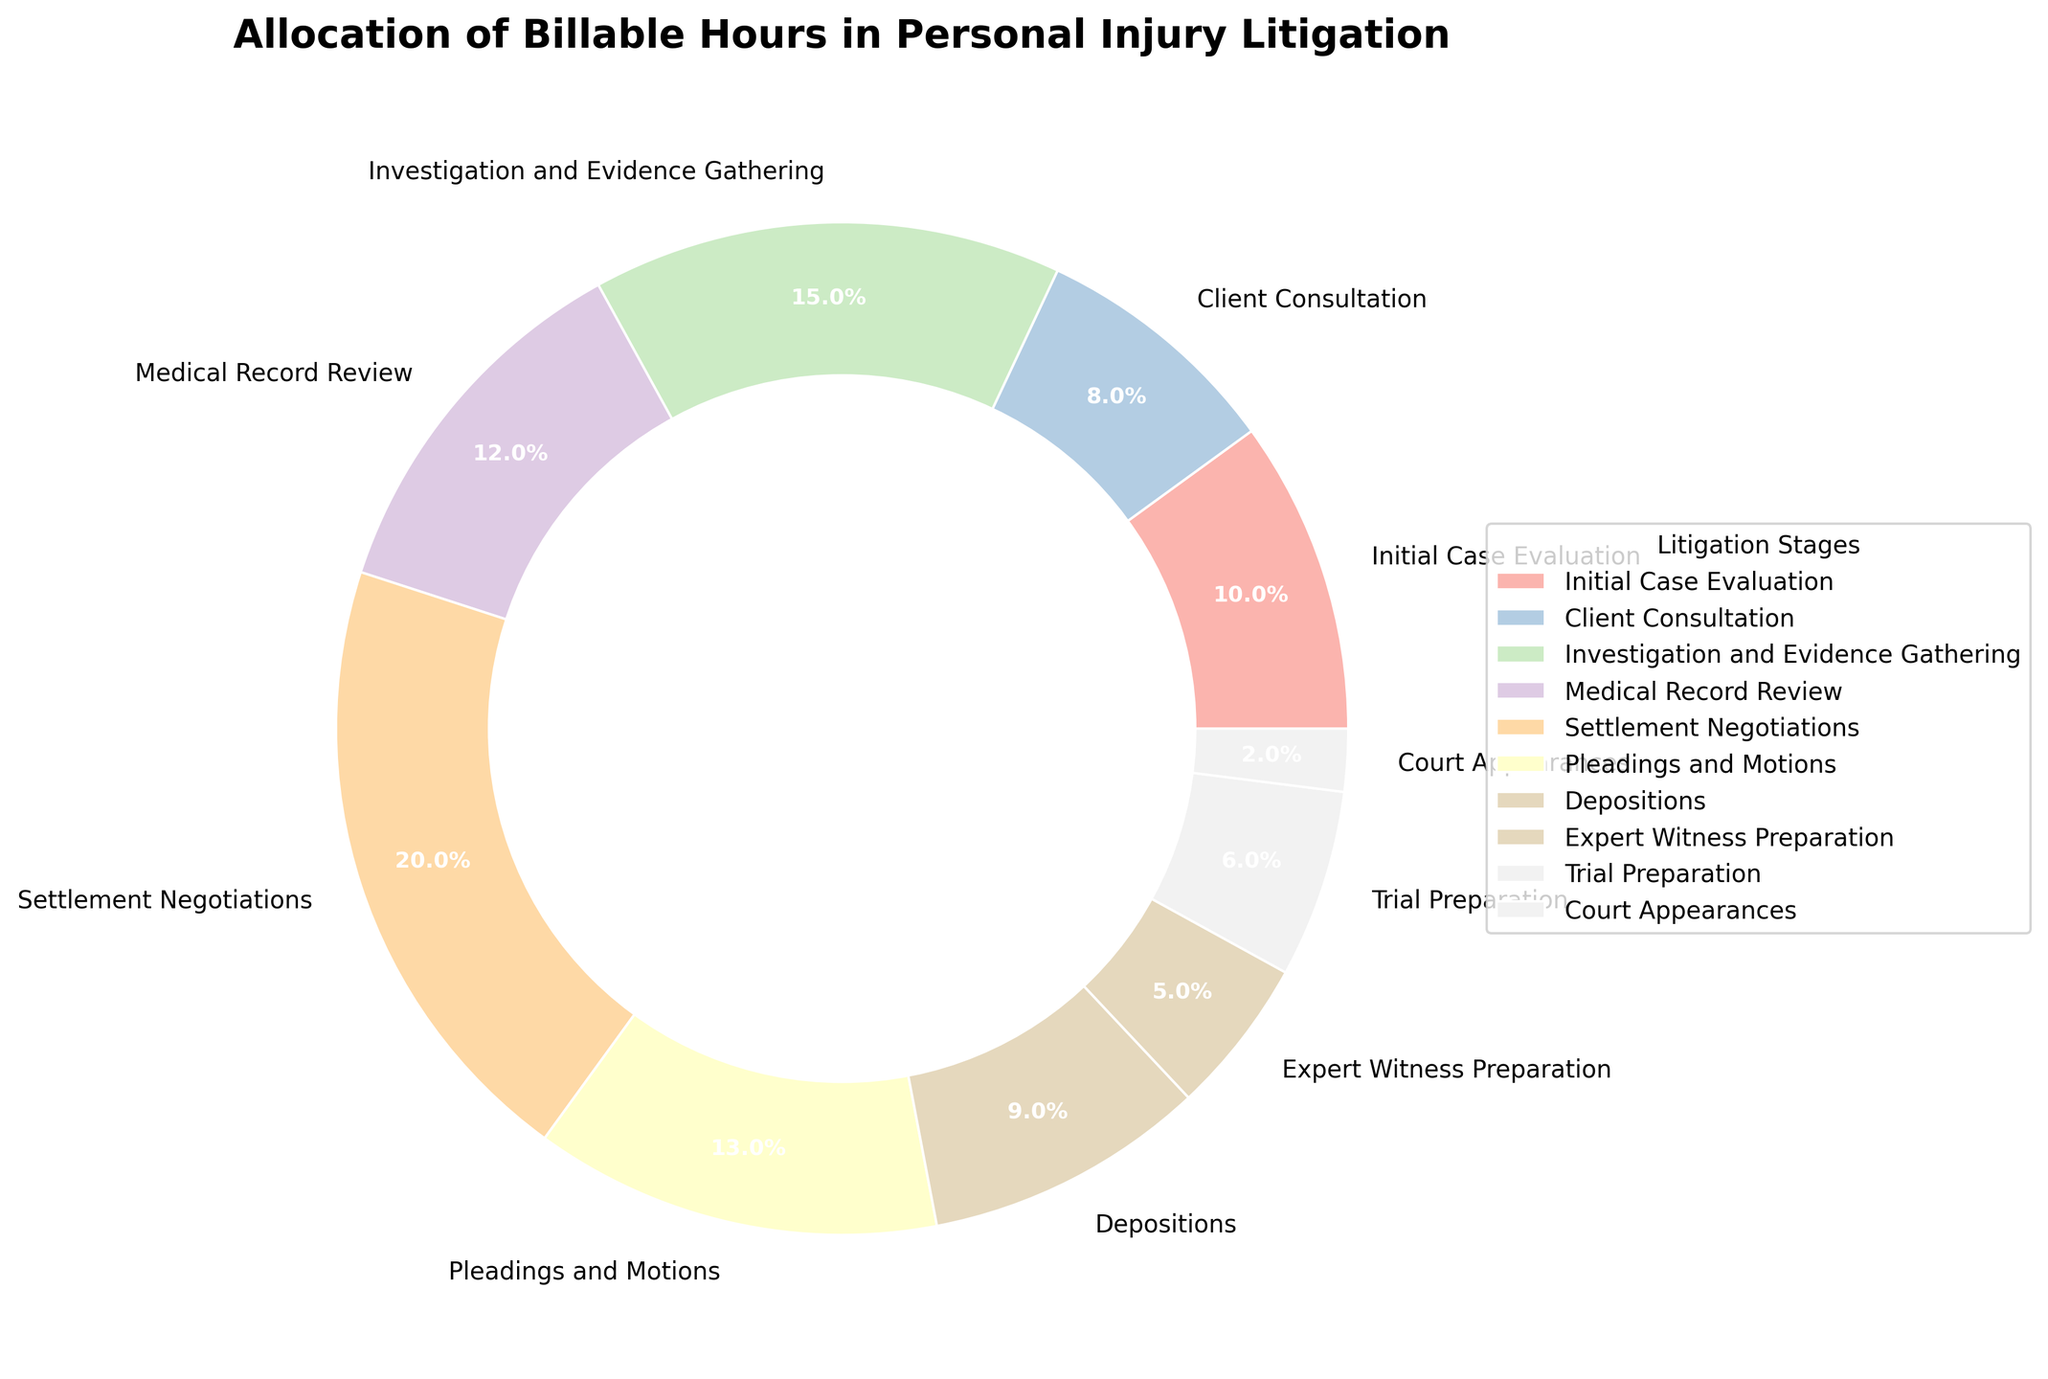What is the percentage allocation for Settlement Negotiations? The percentage for Settlement Negotiations is directly given in the pie chart.
Answer: 20% Which stage has the highest allocation of billable hours? By examining the pie chart, the largest segment represents the stage with the highest percentage.
Answer: Settlement Negotiations What is the combined percentage of Initial Case Evaluation and Medical Record Review? To find the combined percentage, add the percentages of both stages: Initial Case Evaluation (10%) + Medical Record Review (12%).
Answer: 22% Is the allocation for Pleadings and Motions greater than for Investigation and Evidence Gathering? By comparing the segments on the pie chart, the percentages are Pleadings and Motions (13%) and Investigation and Evidence Gathering (15%).
Answer: No What is the difference between the allocations for Client Consultation and Depositions? Subtract the percentage of Depositions from Client Consultation: Client Consultation (8%) - Depositions (9%).
Answer: -1% (Depositions are 1% higher) Which stages have an allocation percentage greater than 10%? Identify the segments with percentages greater than 10%: Initial Case Evaluation (10%), Investigation and Evidence Gathering (15%), Medical Record Review (12%), Settlement Negotiations (20%), Pleadings and Motions (13%).
Answer: Investigation and Evidence Gathering, Medical Record Review, Settlement Negotiations, Pleadings and Motions What is the total allocation percentage for all stages combined? The total percentage of a pie chart always sums to 100%.
Answer: 100% Which stage has the smallest allocation of billable hours? By examining the pie chart, the smallest segment represents the stage with the smallest percentage.
Answer: Court Appearances How much more allocation percentage does Expert Witness Preparation have compared to Court Appearances? Subtract the percentage of Court Appearances from Expert Witness Preparation: Expert Witness Preparation (5%) - Court Appearances (2%).
Answer: 3% What is the difference in allocation percentage between Trial Preparation and Court Appearances? Subtract the percentage of Court Appearances from Trial Preparation: Trial Preparation (6%) - Court Appearances (2%).
Answer: 4% 